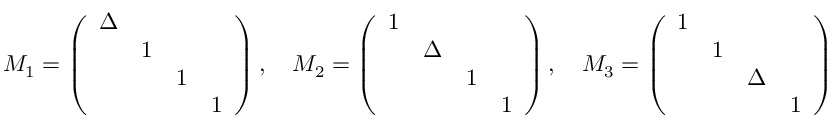<formula> <loc_0><loc_0><loc_500><loc_500>\begin{array} { r } { M _ { 1 } = \left ( \begin{array} { l l l l } { \Delta } & & & \\ & { 1 } & & \\ & & { 1 } & \\ & & & { 1 } \end{array} \right ) , \quad M _ { 2 } = \left ( \begin{array} { l l l l } { 1 } & & & \\ & { \Delta } & & \\ & & { 1 } & \\ & & & { 1 } \end{array} \right ) , \quad M _ { 3 } = \left ( \begin{array} { l l l l } { 1 } & & & \\ & { 1 } & & \\ & & { \Delta } & \\ & & & { 1 } \end{array} \right ) } \end{array}</formula> 